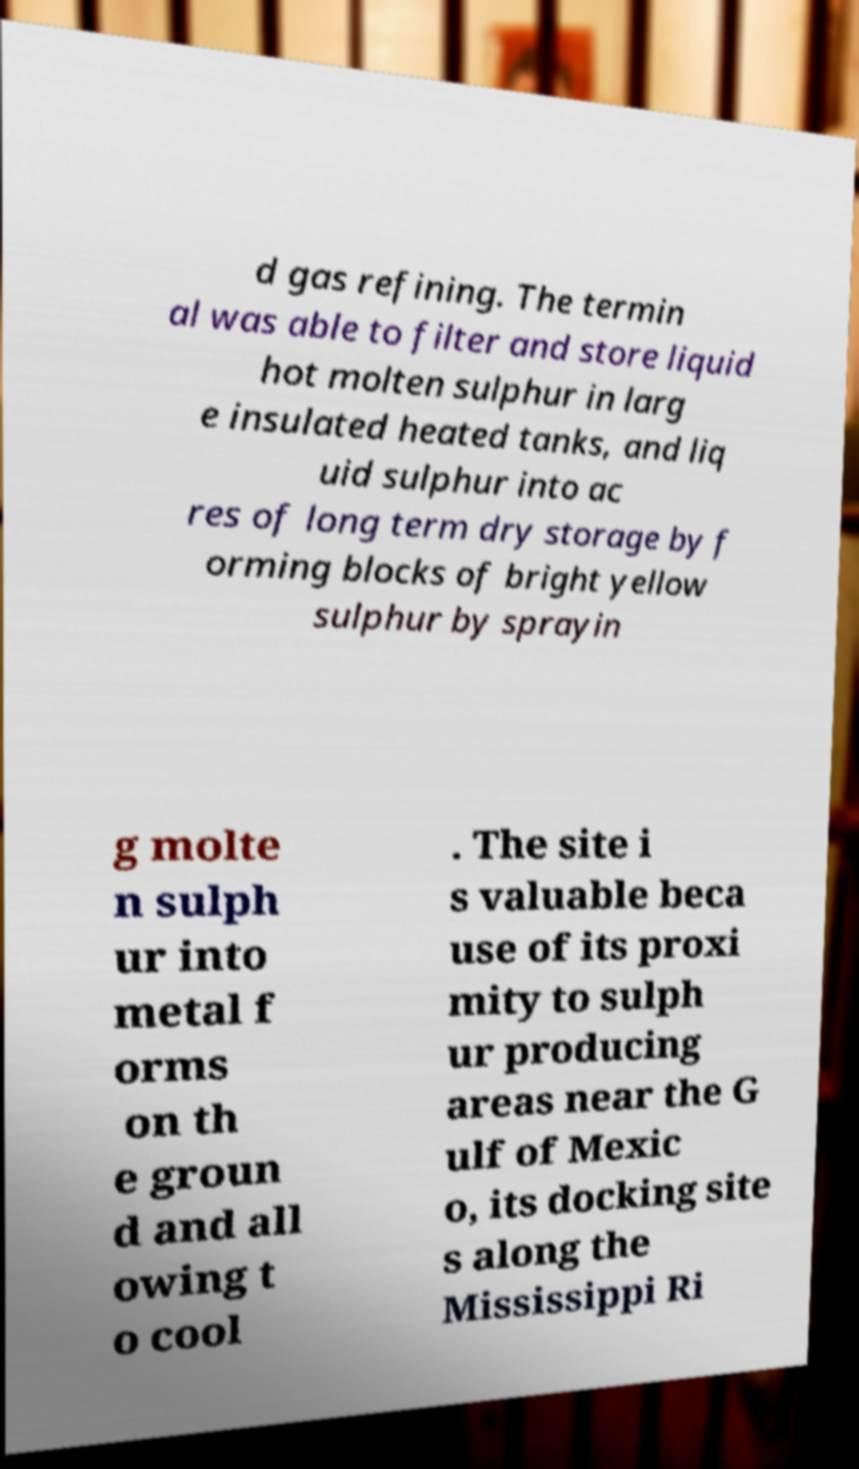What messages or text are displayed in this image? I need them in a readable, typed format. d gas refining. The termin al was able to filter and store liquid hot molten sulphur in larg e insulated heated tanks, and liq uid sulphur into ac res of long term dry storage by f orming blocks of bright yellow sulphur by sprayin g molte n sulph ur into metal f orms on th e groun d and all owing t o cool . The site i s valuable beca use of its proxi mity to sulph ur producing areas near the G ulf of Mexic o, its docking site s along the Mississippi Ri 